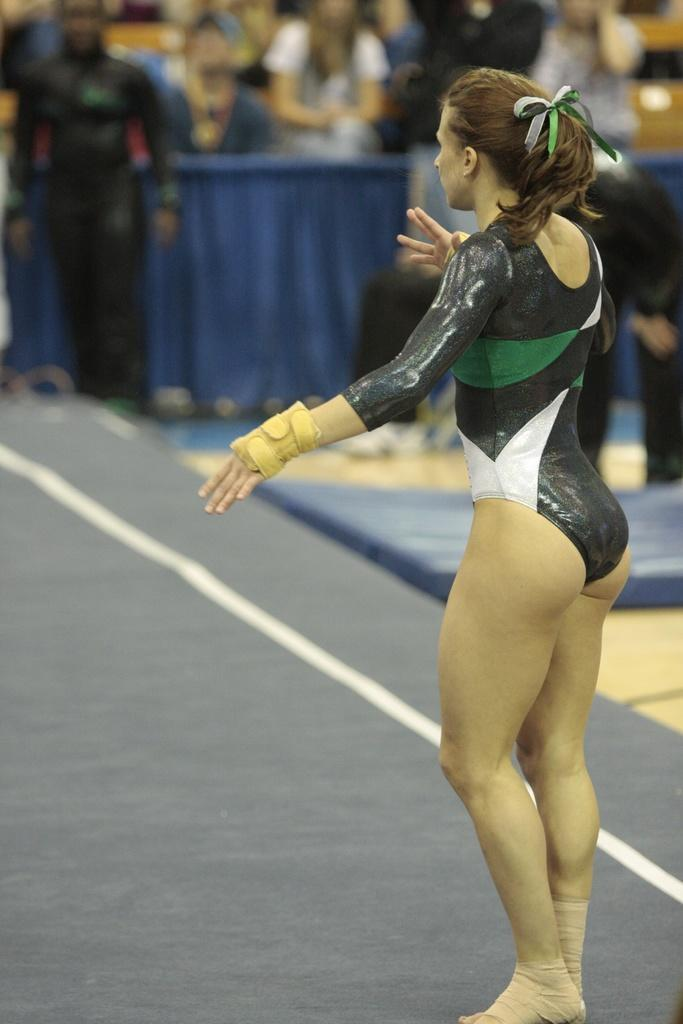What is the woman in the image doing? The woman is standing on a platform. Where is the woman located in the image? The woman is on the right side of the image. Can you describe the background of the image? The image is blurred, but there are people visible in the background. What type of cap is the woman wearing in the image? There is no cap visible on the woman in the image. How does the fog affect the visibility in the image? There is no fog present in the image; it is blurred due to other factors. 